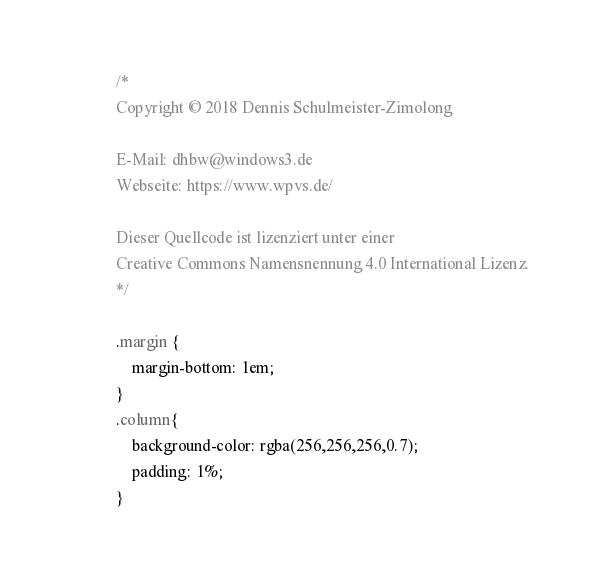<code> <loc_0><loc_0><loc_500><loc_500><_CSS_>/*
Copyright © 2018 Dennis Schulmeister-Zimolong

E-Mail: dhbw@windows3.de
Webseite: https://www.wpvs.de/

Dieser Quellcode ist lizenziert unter einer
Creative Commons Namensnennung 4.0 International Lizenz.
*/

.margin {
    margin-bottom: 1em;
}
.column{
    background-color: rgba(256,256,256,0.7);
    padding: 1%;
}</code> 